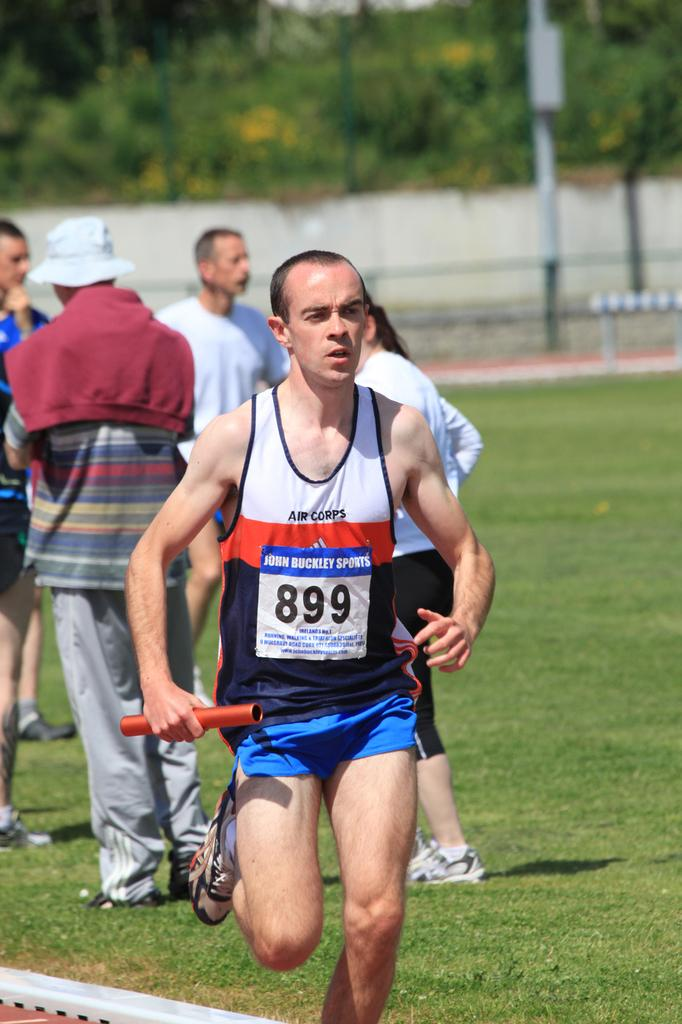Provide a one-sentence caption for the provided image. A man running a race is wearing the numbers 899. 